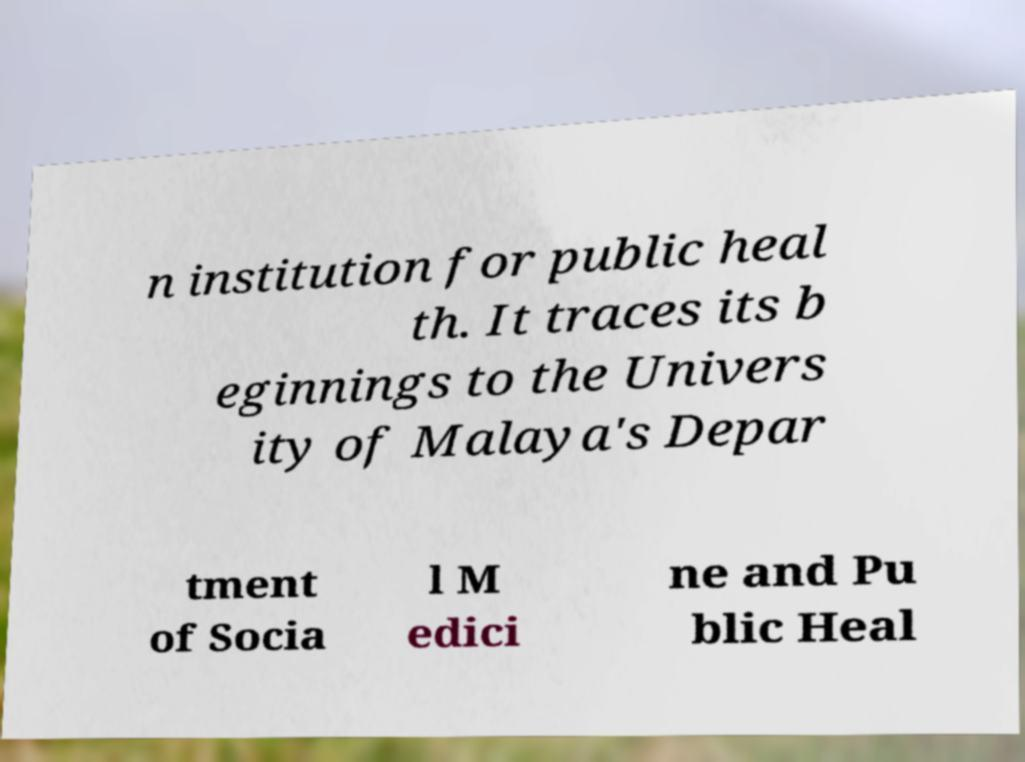Can you read and provide the text displayed in the image?This photo seems to have some interesting text. Can you extract and type it out for me? n institution for public heal th. It traces its b eginnings to the Univers ity of Malaya's Depar tment of Socia l M edici ne and Pu blic Heal 